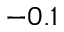Convert formula to latex. <formula><loc_0><loc_0><loc_500><loc_500>- 0 . 1</formula> 